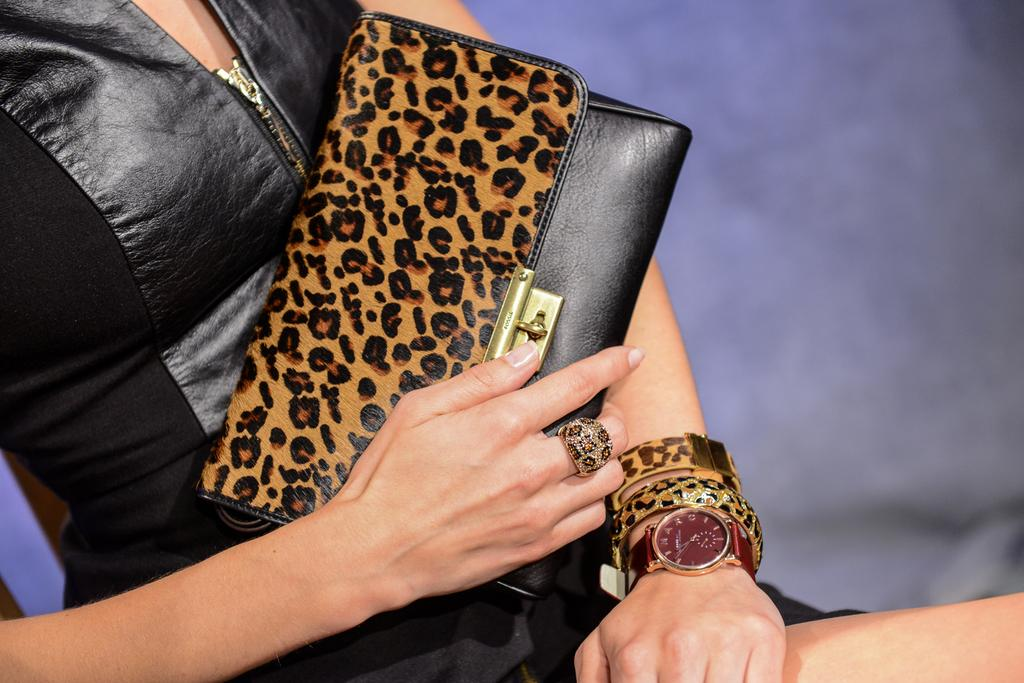Who is the main subject in the image? There is a lady in the image. What is the lady holding in the image? The lady is holding a purse. What is the lady wearing in the image? The lady is wearing a black dress. What type of tin can be seen in the lady's hand in the image? There is no tin present in the image; the lady is holding a purse. 